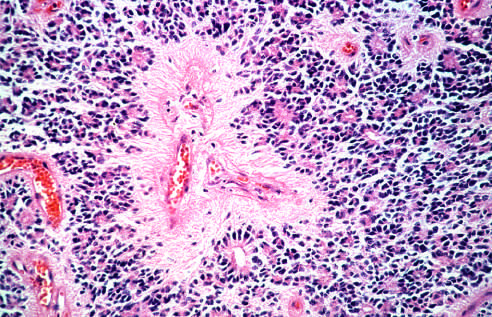what do tumor cells have in oligodendroglioma?
Answer the question using a single word or phrase. Round nuclei 